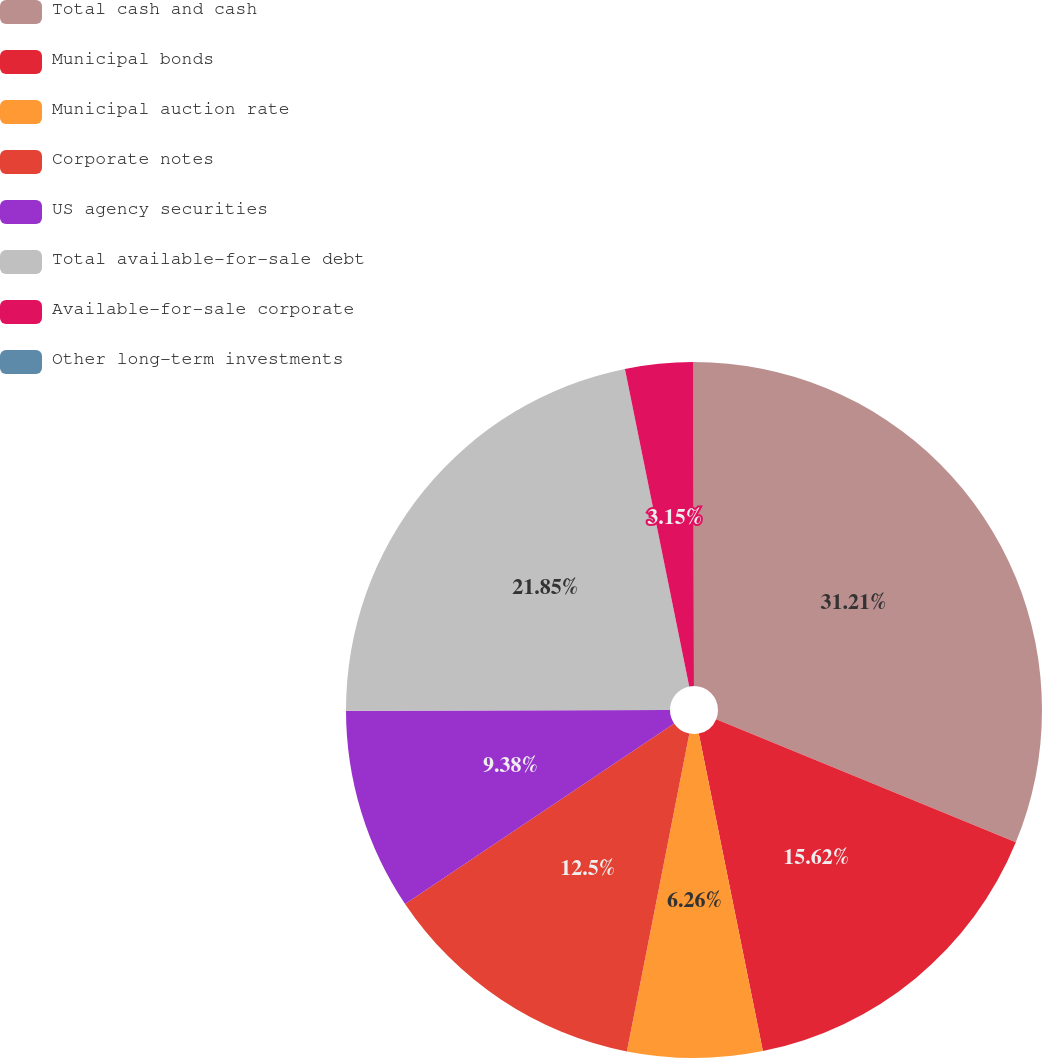Convert chart to OTSL. <chart><loc_0><loc_0><loc_500><loc_500><pie_chart><fcel>Total cash and cash<fcel>Municipal bonds<fcel>Municipal auction rate<fcel>Corporate notes<fcel>US agency securities<fcel>Total available-for-sale debt<fcel>Available-for-sale corporate<fcel>Other long-term investments<nl><fcel>31.21%<fcel>15.62%<fcel>6.26%<fcel>12.5%<fcel>9.38%<fcel>21.85%<fcel>3.15%<fcel>0.03%<nl></chart> 